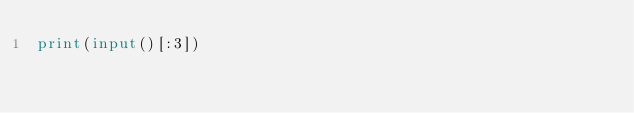Convert code to text. <code><loc_0><loc_0><loc_500><loc_500><_Python_>print(input()[:3])</code> 